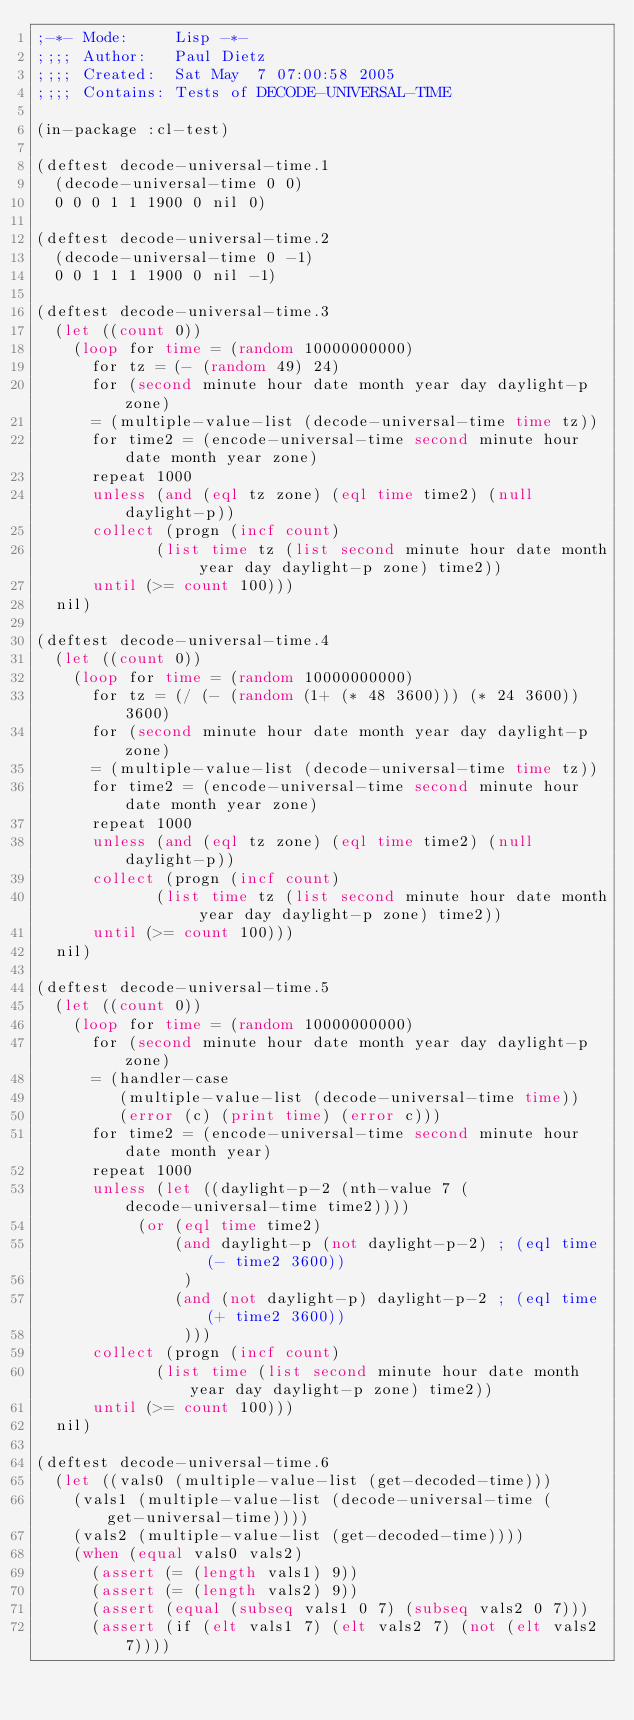Convert code to text. <code><loc_0><loc_0><loc_500><loc_500><_Lisp_>;-*- Mode:     Lisp -*-
;;;; Author:   Paul Dietz
;;;; Created:  Sat May  7 07:00:58 2005
;;;; Contains: Tests of DECODE-UNIVERSAL-TIME

(in-package :cl-test)

(deftest decode-universal-time.1
  (decode-universal-time 0 0)
  0 0 0 1 1 1900 0 nil 0)

(deftest decode-universal-time.2
  (decode-universal-time 0 -1)
  0 0 1 1 1 1900 0 nil -1)

(deftest decode-universal-time.3
  (let ((count 0))
    (loop for time = (random 10000000000)
	  for tz = (- (random 49) 24)
	  for (second minute hour date month year day daylight-p zone)
	  = (multiple-value-list (decode-universal-time time tz))
	  for time2 = (encode-universal-time second minute hour date month year zone)
	  repeat 1000
	  unless (and (eql tz zone) (eql time time2) (null daylight-p))
	  collect (progn (incf count)
			 (list time tz (list second minute hour date month year day daylight-p zone) time2))
	  until (>= count 100)))
  nil)

(deftest decode-universal-time.4
  (let ((count 0))
    (loop for time = (random 10000000000)
	  for tz = (/ (- (random (1+ (* 48 3600))) (* 24 3600)) 3600)
	  for (second minute hour date month year day daylight-p zone)
	  = (multiple-value-list (decode-universal-time time tz))
	  for time2 = (encode-universal-time second minute hour date month year zone)
	  repeat 1000
	  unless (and (eql tz zone) (eql time time2) (null daylight-p))
	  collect (progn (incf count)
			 (list time tz (list second minute hour date month year day daylight-p zone) time2))
	  until (>= count 100)))
  nil)

(deftest decode-universal-time.5
  (let ((count 0))
    (loop for time = (random 10000000000)
	  for (second minute hour date month year day daylight-p zone)
	  = (handler-case
	     (multiple-value-list (decode-universal-time time))
	     (error (c) (print time) (error c)))
	  for time2 = (encode-universal-time second minute hour date month year)
	  repeat 1000
	  unless (let ((daylight-p-2 (nth-value 7 (decode-universal-time time2))))
		   (or (eql time time2)
		       (and daylight-p (not daylight-p-2) ; (eql time (- time2 3600))
			    )
		       (and (not daylight-p) daylight-p-2 ; (eql time (+ time2 3600))
			    )))
	  collect (progn (incf count)
			 (list time (list second minute hour date month year day daylight-p zone) time2))
	  until (>= count 100)))
  nil)

(deftest decode-universal-time.6
  (let ((vals0 (multiple-value-list (get-decoded-time)))
	(vals1 (multiple-value-list (decode-universal-time (get-universal-time))))
	(vals2 (multiple-value-list (get-decoded-time))))
    (when (equal vals0 vals2)
      (assert (= (length vals1) 9))
      (assert (= (length vals2) 9))
      (assert (equal (subseq vals1 0 7) (subseq vals2 0 7)))
      (assert (if (elt vals1 7) (elt vals2 7) (not (elt vals2 7))))</code> 